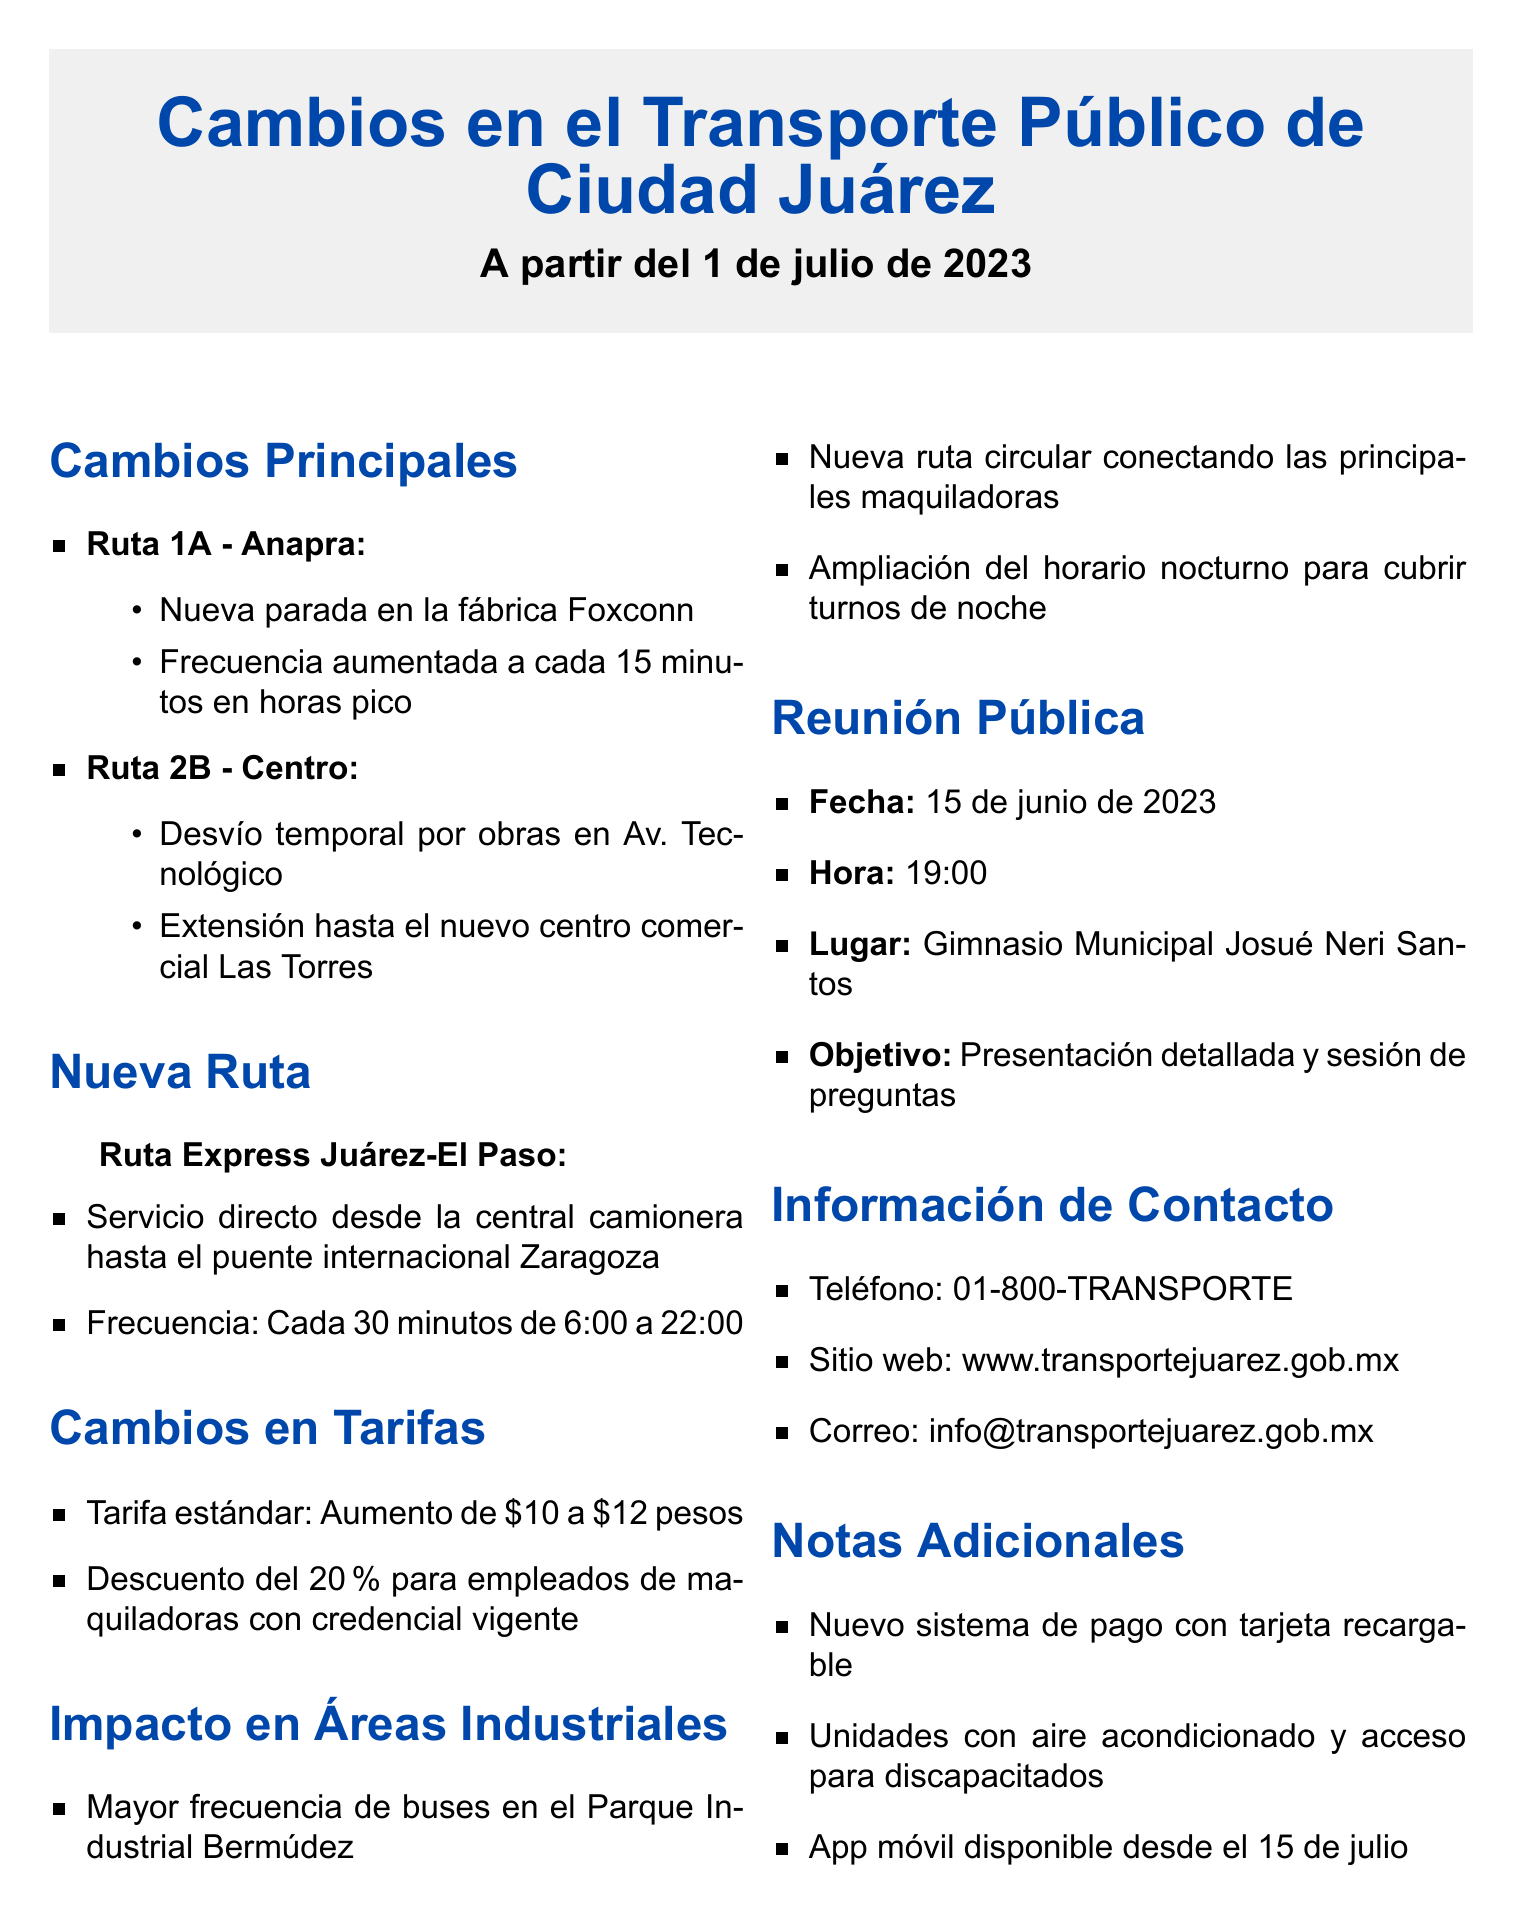¿Cuándo se implementan los cambios en el transporte público? La fecha de efectividad de los cambios descritos en el documento es el 1 de julio de 2023.
Answer: 1 de julio de 2023 ¿Qué nueva parada se añade a la Ruta 1A? La Ruta 1A - Anapra tendrá una nueva parada en la fábrica Foxconn.
Answer: fábrica Foxconn ¿Cuál es el nuevo costo de la tarifa estándar? El documento indica que la tarifa estándar aumentará de $10 a $12 pesos.
Answer: $12 pesos ¿Qué frecuencia tendrá la nueva Ruta Express Juárez-El Paso? Esta nueva ruta operará cada 30 minutos de 6:00 a 22:00.
Answer: Cada 30 minutos ¿Cuándo es la reunión pública para discutir los cambios? La reunión pública está programada para el 15 de junio de 2023.
Answer: 15 de junio de 2023 ¿Qué beneficio se ofrecerá a los empleados de maquiladoras en las tarifas? Los empleados de maquiladoras tendrán un descuento del 20% con una credencial vigente.
Answer: Descuento del 20% ¿Qué nuevas características tendrán las unidades de transporte? Las nuevas unidades estarán equipadas con aire acondicionado y acceso para personas con discapacidad.
Answer: aire acondicionado y acceso para personas con discapacidad ¿Cuál es el propósito de la reunión pública? El objetivo de la reunión es presentar los cambios de manera detallada y permitir una sesión de preguntas.
Answer: Presentación detallada y sesión de preguntas ¿Qué se implementará para facilitar el pago del transporte? Se implementará un sistema de pago con tarjeta recargable.
Answer: sistema de pago con tarjeta recargable 